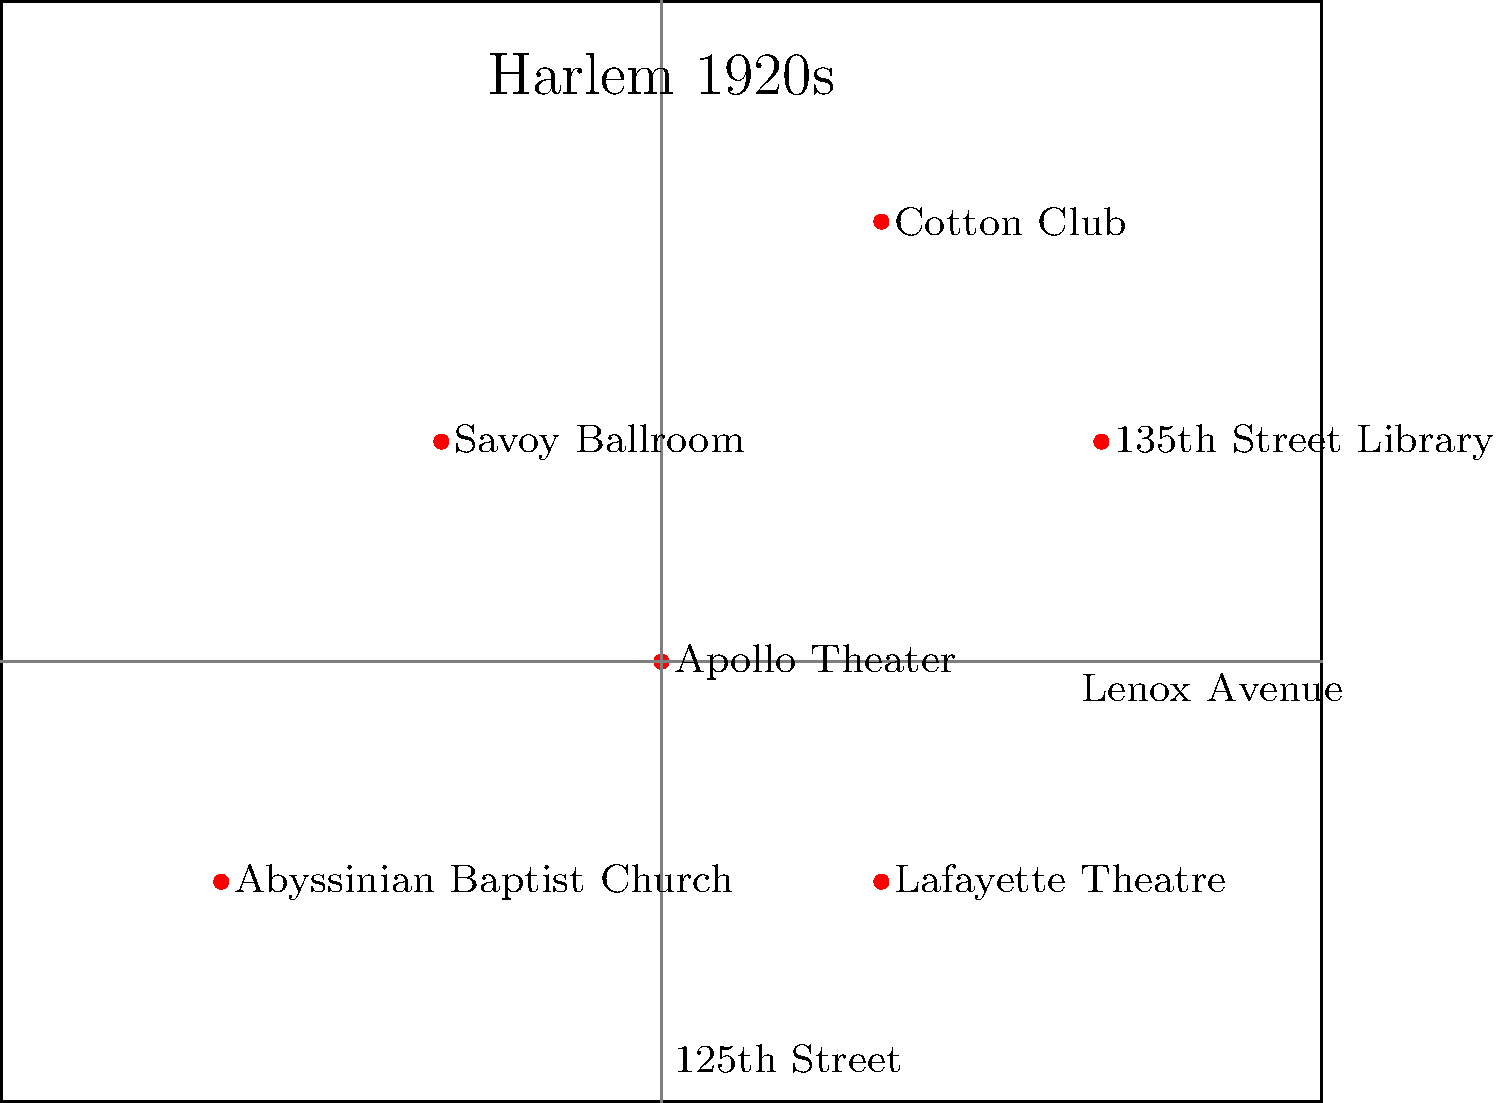Analyze the visual elements in this map of 1920s Harlem. How does the spatial arrangement of key cultural institutions reflect the interconnectedness and vibrancy of the Harlem Renaissance movement? Consider the proximity of venues and their potential impact on the flow of ideas and artistic expression. 1. Identify key locations: The map shows six significant cultural institutions of the Harlem Renaissance: Apollo Theater, Cotton Club, Savoy Ballroom, 135th Street Library, Abyssinian Baptist Church, and Lafayette Theatre.

2. Analyze spatial arrangement: These locations are distributed across different parts of Harlem, indicating a widespread cultural movement.

3. Proximity analysis:
   a. The Apollo Theater and Cotton Club are relatively close, suggesting a concentration of musical venues.
   b. The 135th Street Library is centrally located, potentially serving as an intellectual hub.
   c. The Savoy Ballroom and Lafayette Theatre are in different areas, spreading cultural activities throughout Harlem.

4. Street layout: Lenox Avenue and 125th Street are highlighted, showing major thoroughfares that connected these institutions.

5. Interconnectedness: The relatively close proximity of these venues facilitated easy movement between them, encouraging the exchange of ideas and artistic collaboration.

6. Diversity of institutions: The map includes theaters, clubs, a library, and a church, representing the multifaceted nature of the Harlem Renaissance (music, literature, spirituality).

7. Cultural density: The concentration of so many significant venues in a relatively small area underscores the intensity and vibrancy of the Harlem Renaissance movement.

8. Accessibility: The layout suggests that residents and visitors could easily access multiple cultural institutions, fostering a rich, immersive experience of the Renaissance.

This spatial arrangement reflects the Harlem Renaissance's interconnectedness by showing how closely linked these cultural centers were, facilitating the flow of ideas, artistic expression, and community engagement that defined this pivotal period in African American cultural history.
Answer: The map's spatial arrangement reflects the Harlem Renaissance's interconnectedness by showing the proximity and diversity of key cultural institutions, facilitating idea exchange and artistic collaboration across literature, music, and spirituality. 